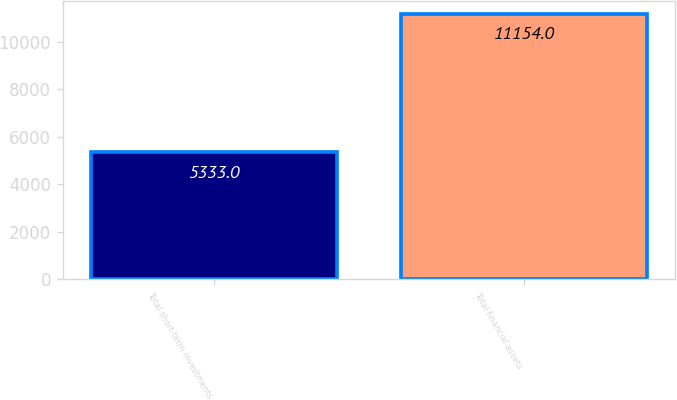<chart> <loc_0><loc_0><loc_500><loc_500><bar_chart><fcel>Total short-term investments<fcel>Total financial assets<nl><fcel>5333<fcel>11154<nl></chart> 